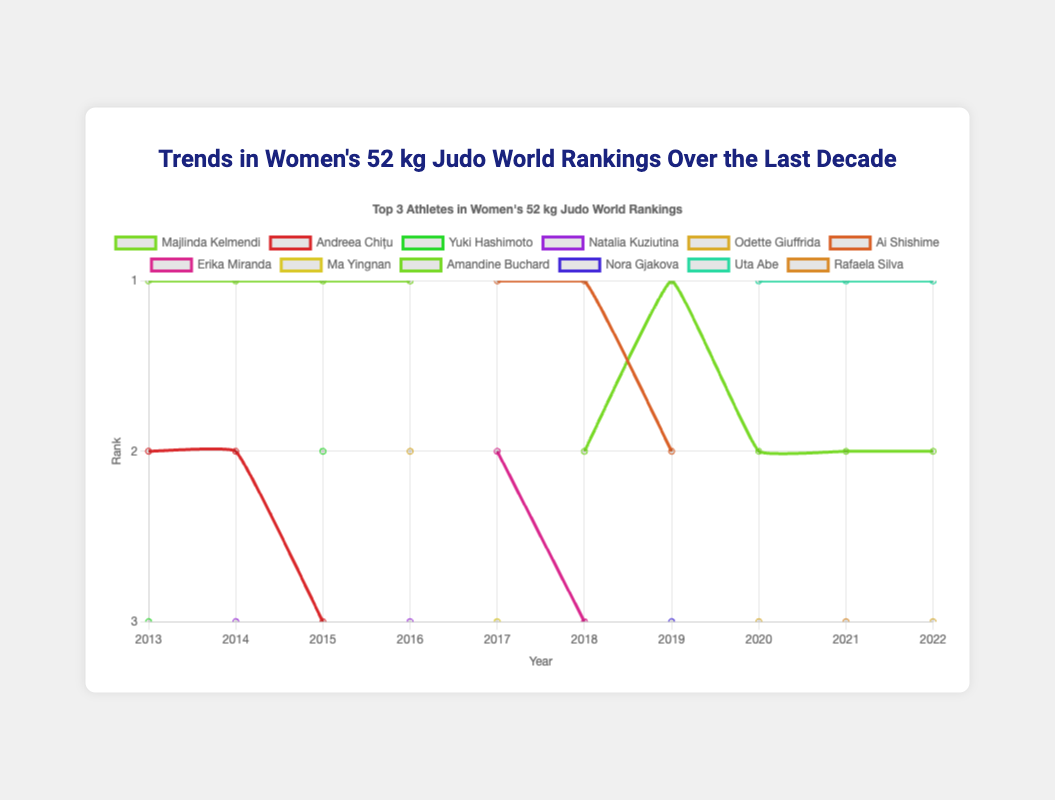Which athlete appeared most frequently at the first rank over the last decade? To find the athlete with the most first-place finishes, we count the appearances for each athlete at rank 1. Majlinda Kelmendi had the first rank from 2013 to 2016, which is 4 times. Uta Abe held the first rank from 2020 to 2022, which is 3 times. Therefore, Majlinda Kelmendi is the one appearing most frequently at the first rank.
Answer: Majlinda Kelmendi How did the ranking of Amandine Buchard change over the years? Amandine Buchard appeared in the rankings starting from 2018. From the visualization, she was ranked 2nd in 2018, 2019, 2020, 2021, and 2022. This shows consistency in her performance over the years.
Answer: Consistent at 2nd rank Which year saw the most diverse set of countries in the top 3 rankings? To determine this, we look at the number of unique countries each year in the top 3 positions. In 2013 and 2014, there were 3 different countries represented in the top 3 rankings. In 2017, 3 different countries (Japan, Brazil, China) appeared again in the top 3, indicating the highest diversity in those years.
Answer: 2013, 2014, 2017 Which country had the highest number of appearances in the top 3 over the last decade? Here, we count the total number of appearances of each country in the top 3 rankings over the years. Japan appears consistently from 2013 to 2022. Calculating the number of times Japan appears in the rankings: 2013 - 1, 2014 - 1, 2015 - 1, 2016 - 0, 2017 -1, 2018 -1, 2019 -1, 2020 -1, 2021 -1, 2022 -1. This sums up to a total of 9 appearances. No other country has appeared this frequently.
Answer: Japan What was the longest consecutive streak for any single athlete to be ranked at the top? To find the longest streak, we examine each athlete's ranking continuity. Majlinda Kelmendi held the top rank from 2013 through 2016, thus achieving a continuous 4-year streak. Uta Abe held the top rank from 2020 through 2022, which is a 3-year streak. Therefore, Majlinda Kelmendi has the longest consecutive streak at 4 years.
Answer: 4 years Who ranked 3rd three times in a row from 2014 to 2016? Checking the 3rd place rankings from 2014 to 2016: Natalia Kuziutina was ranked 3rd in 2014 and 2016, while Andreea Chițu was 3rd in 2015. No single athlete ranked 3rd three consecutive times during this period.
Answer: No one Which athlete's ranking dropped out of the top 3 after leading in 2016? In 2016, Majlinda Kelmendi was the leader, and by 2017, she is not in the top 3 rankings. Therefore, Majlinda Kelmendi dropped out of the top 3 following 2016.
Answer: Majlinda Kelmendi Which athlete showed the most improvement in their ranking from 2018 to 2019? Checking the ranks from 2018 to 2019, Amandine Buchard improved from 2nd in 2018 to leading at 1st in 2019. This makes her the athlete with the most improvement in ranking for that period.
Answer: Amandine Buchard Was any athlete consistently in the top 3 every year from 2020 to 2022? Observing the ranks from 2020 to 2022, Amandine Buchard consistently appears in the top 3, specifically in the 2nd position each year.
Answer: Yes, Amandine Buchard 